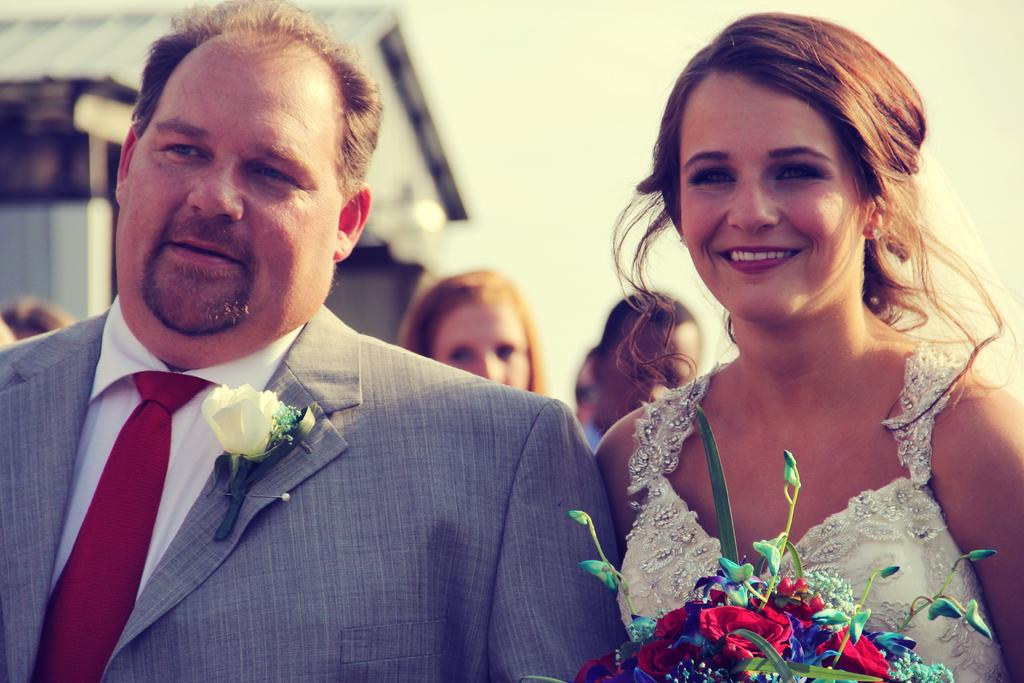What can be seen in the image? There is a group of people in the image. What is the woman holding in the image? The woman is holding a bouquet. Can you describe the background of the image? The background of the image is blurred. Where is the dock located in the image? There is no dock present in the image. What type of crow is perched on the woman's shoulder in the image? There is no crow present in the image. 